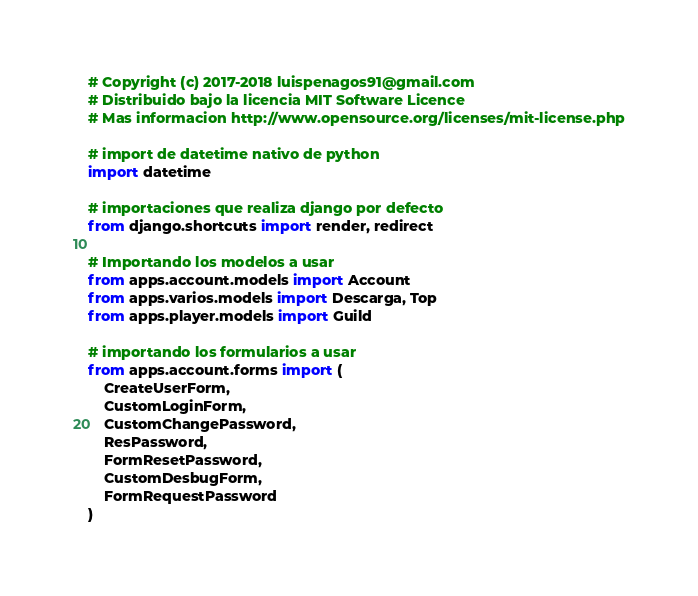<code> <loc_0><loc_0><loc_500><loc_500><_Python_># Copyright (c) 2017-2018 luispenagos91@gmail.com
# Distribuido bajo la licencia MIT Software Licence
# Mas informacion http://www.opensource.org/licenses/mit-license.php

# import de datetime nativo de python
import datetime

# importaciones que realiza django por defecto
from django.shortcuts import render, redirect

# Importando los modelos a usar
from apps.account.models import Account
from apps.varios.models import Descarga, Top
from apps.player.models import Guild

# importando los formularios a usar
from apps.account.forms import (
    CreateUserForm,
    CustomLoginForm,
    CustomChangePassword,
    ResPassword,
    FormResetPassword,
    CustomDesbugForm,
    FormRequestPassword
)
</code> 